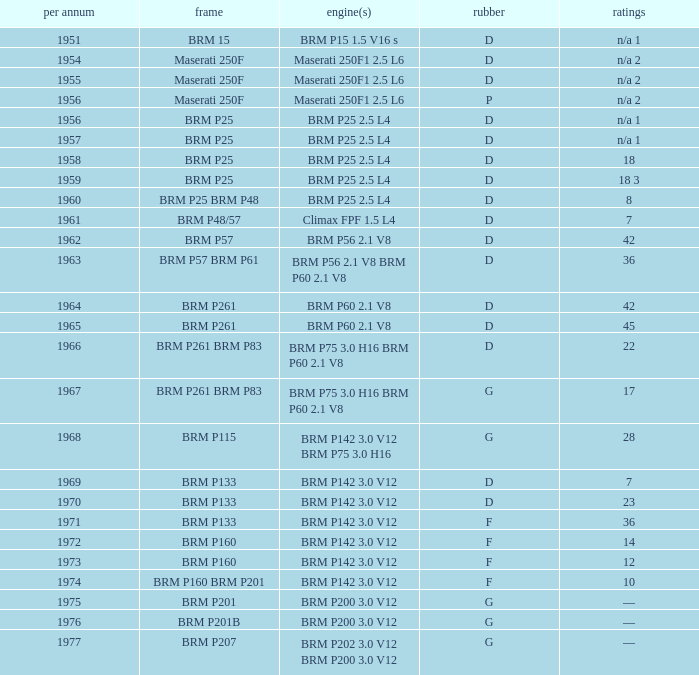Name the chassis of 1961 BRM P48/57. 